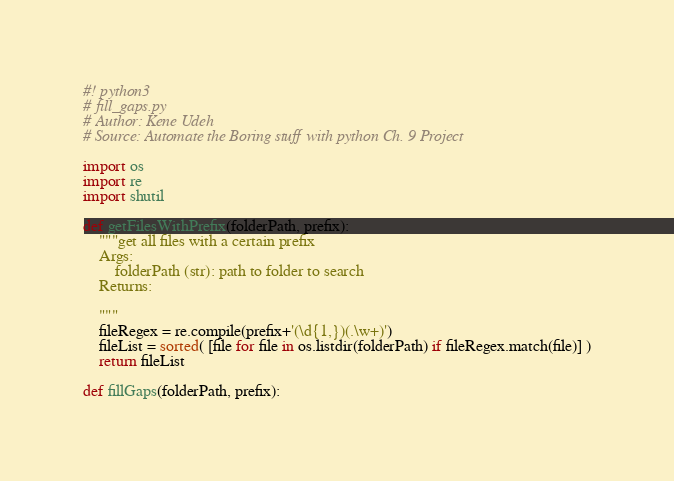<code> <loc_0><loc_0><loc_500><loc_500><_Python_>#! python3
# fill_gaps.py
# Author: Kene Udeh
# Source: Automate the Boring stuff with python Ch. 9 Project

import os
import re
import shutil

def getFilesWithPrefix(folderPath, prefix):
    """get all files with a certain prefix
    Args:
        folderPath (str): path to folder to search
    Returns:

    """
    fileRegex = re.compile(prefix+'(\d{1,})(.\w+)')
    fileList = sorted( [file for file in os.listdir(folderPath) if fileRegex.match(file)] )
    return fileList

def fillGaps(folderPath, prefix):</code> 